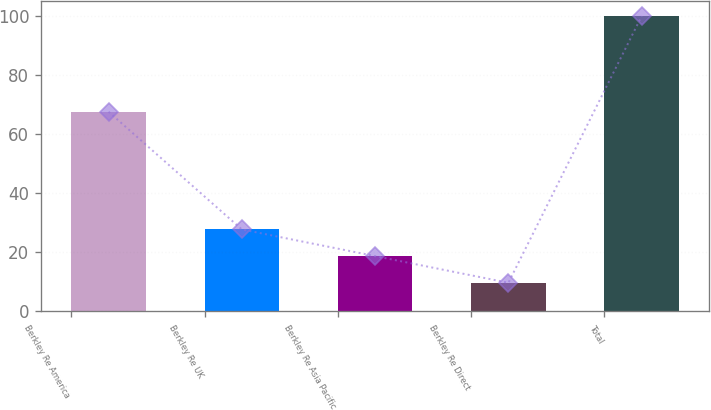Convert chart. <chart><loc_0><loc_0><loc_500><loc_500><bar_chart><fcel>Berkley Re America<fcel>Berkley Re UK<fcel>Berkley Re Asia Pacific<fcel>Berkley Re Direct<fcel>Total<nl><fcel>67.6<fcel>27.76<fcel>18.73<fcel>9.7<fcel>100<nl></chart> 